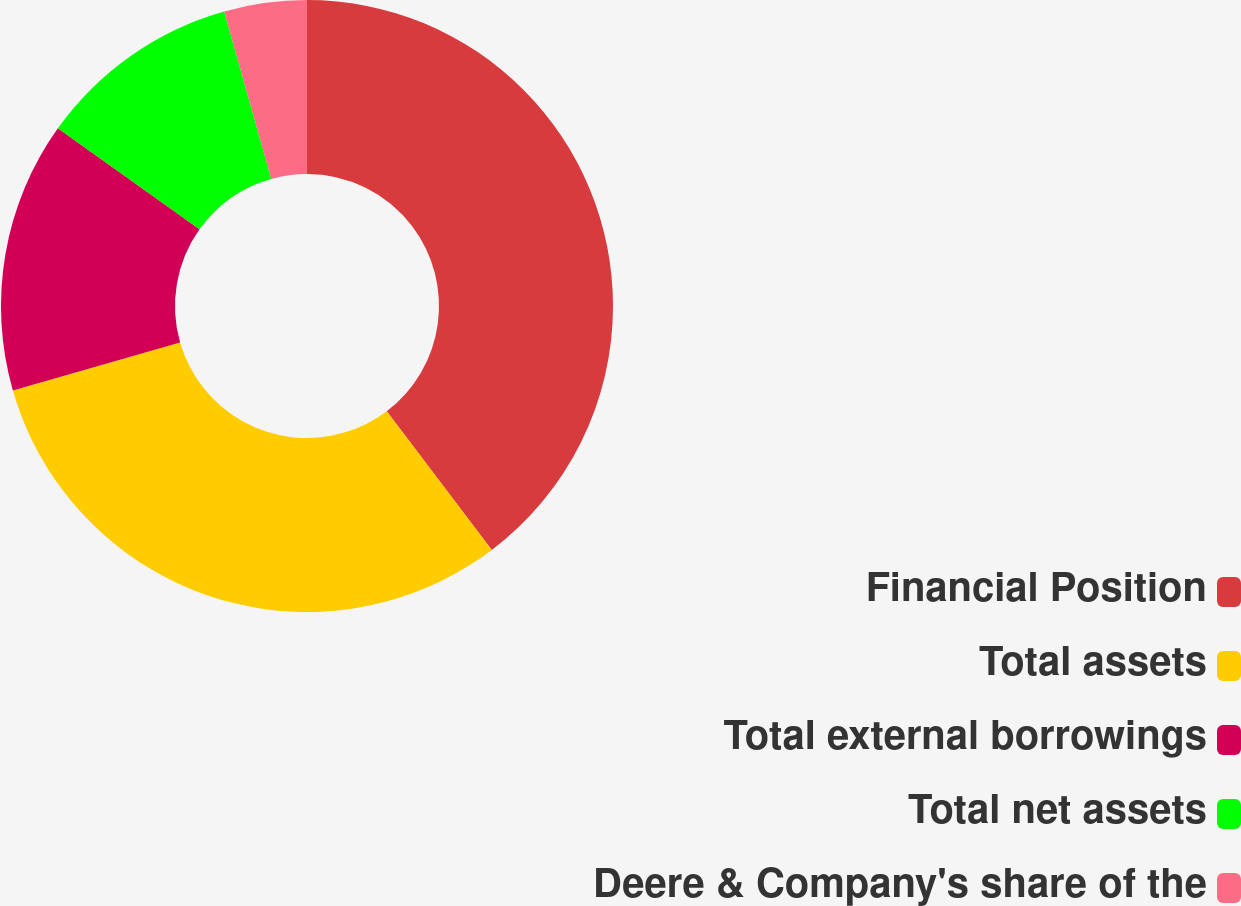Convert chart. <chart><loc_0><loc_0><loc_500><loc_500><pie_chart><fcel>Financial Position<fcel>Total assets<fcel>Total external borrowings<fcel>Total net assets<fcel>Deere & Company's share of the<nl><fcel>39.68%<fcel>30.87%<fcel>14.31%<fcel>10.78%<fcel>4.36%<nl></chart> 